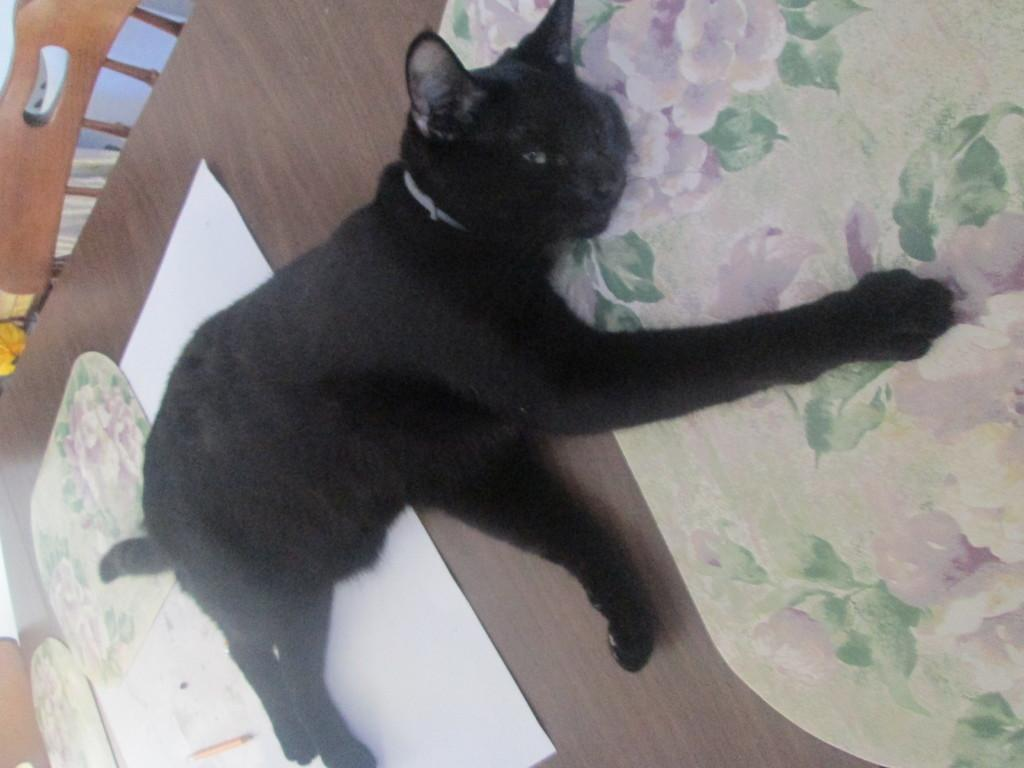What type of animal is lying on the table in the image? There is a black cat lying on the table in the image. What else is on the table besides the cat? There is a white paper on the table. Is there any furniture visible in the image? Yes, there is a chair beside the table. What is the current market value of the fifth item on the table? There are only three items mentioned in the image (the black cat, the white paper, and the chair), so it's not possible to determine the market value of a fifth item. 